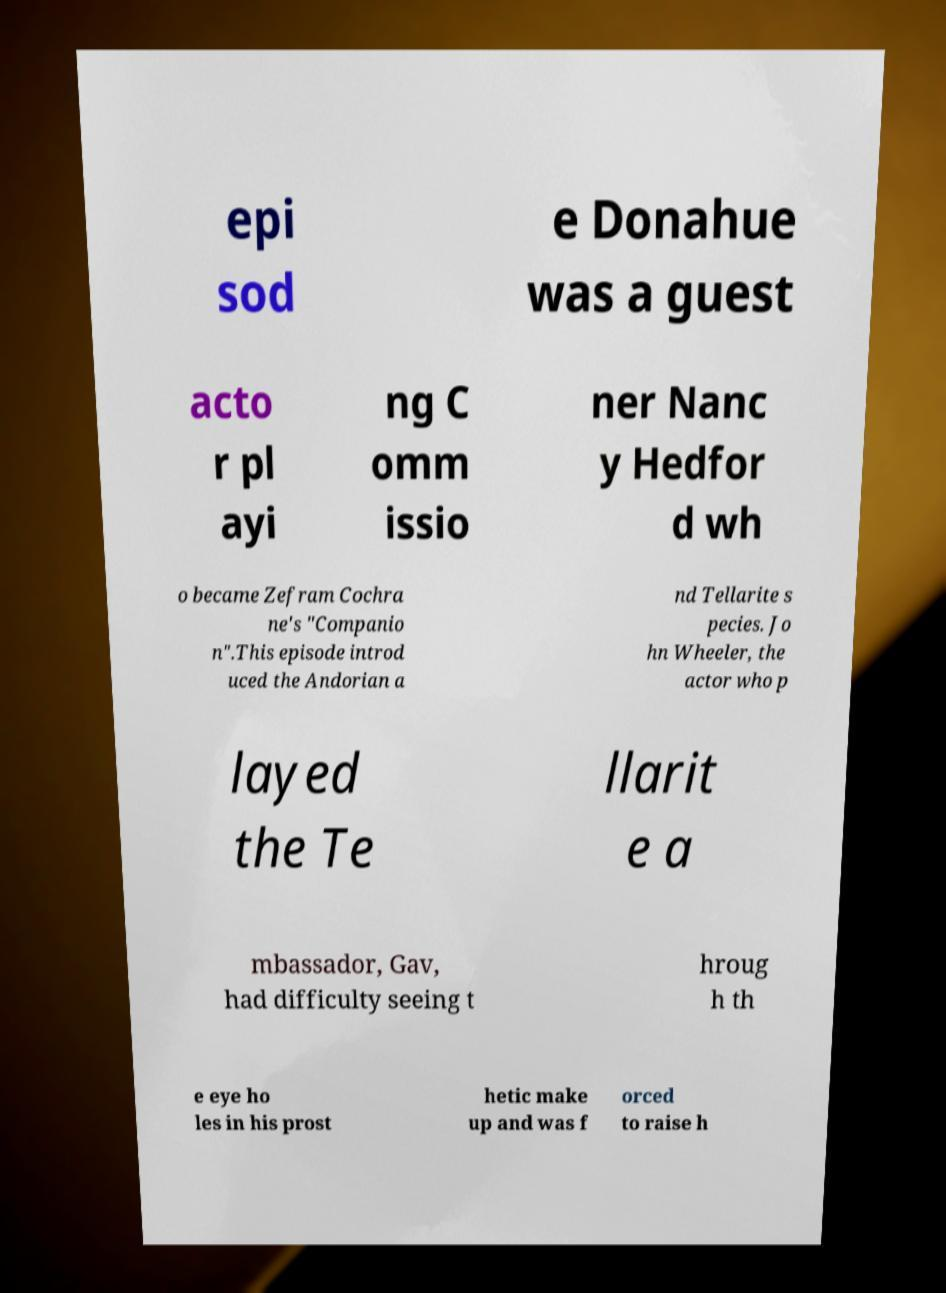I need the written content from this picture converted into text. Can you do that? epi sod e Donahue was a guest acto r pl ayi ng C omm issio ner Nanc y Hedfor d wh o became Zefram Cochra ne's "Companio n".This episode introd uced the Andorian a nd Tellarite s pecies. Jo hn Wheeler, the actor who p layed the Te llarit e a mbassador, Gav, had difficulty seeing t hroug h th e eye ho les in his prost hetic make up and was f orced to raise h 